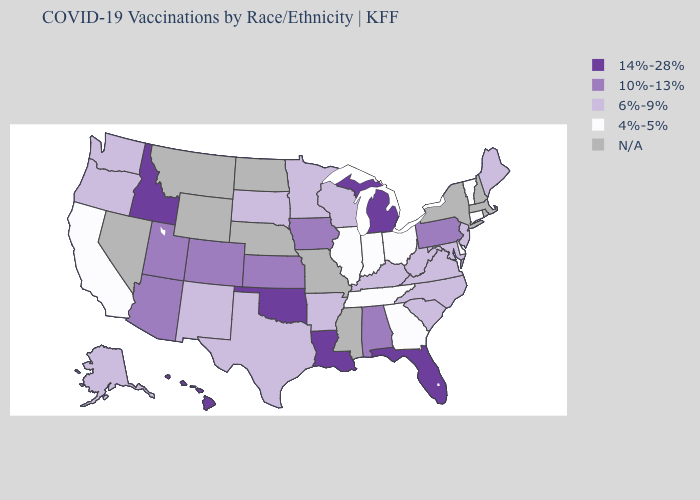What is the highest value in the Northeast ?
Keep it brief. 10%-13%. Does the map have missing data?
Give a very brief answer. Yes. Name the states that have a value in the range 6%-9%?
Quick response, please. Alaska, Arkansas, Kentucky, Maine, Maryland, Minnesota, New Jersey, New Mexico, North Carolina, Oregon, South Carolina, South Dakota, Texas, Virginia, Washington, West Virginia, Wisconsin. What is the value of Nevada?
Be succinct. N/A. What is the lowest value in the Northeast?
Answer briefly. 4%-5%. What is the value of Ohio?
Short answer required. 4%-5%. Name the states that have a value in the range N/A?
Short answer required. Massachusetts, Mississippi, Missouri, Montana, Nebraska, Nevada, New Hampshire, New York, North Dakota, Rhode Island, Wyoming. Name the states that have a value in the range 6%-9%?
Give a very brief answer. Alaska, Arkansas, Kentucky, Maine, Maryland, Minnesota, New Jersey, New Mexico, North Carolina, Oregon, South Carolina, South Dakota, Texas, Virginia, Washington, West Virginia, Wisconsin. What is the highest value in the MidWest ?
Answer briefly. 14%-28%. Name the states that have a value in the range 6%-9%?
Be succinct. Alaska, Arkansas, Kentucky, Maine, Maryland, Minnesota, New Jersey, New Mexico, North Carolina, Oregon, South Carolina, South Dakota, Texas, Virginia, Washington, West Virginia, Wisconsin. Does Connecticut have the lowest value in the USA?
Answer briefly. Yes. Does Tennessee have the lowest value in the USA?
Answer briefly. Yes. What is the lowest value in the USA?
Keep it brief. 4%-5%. 